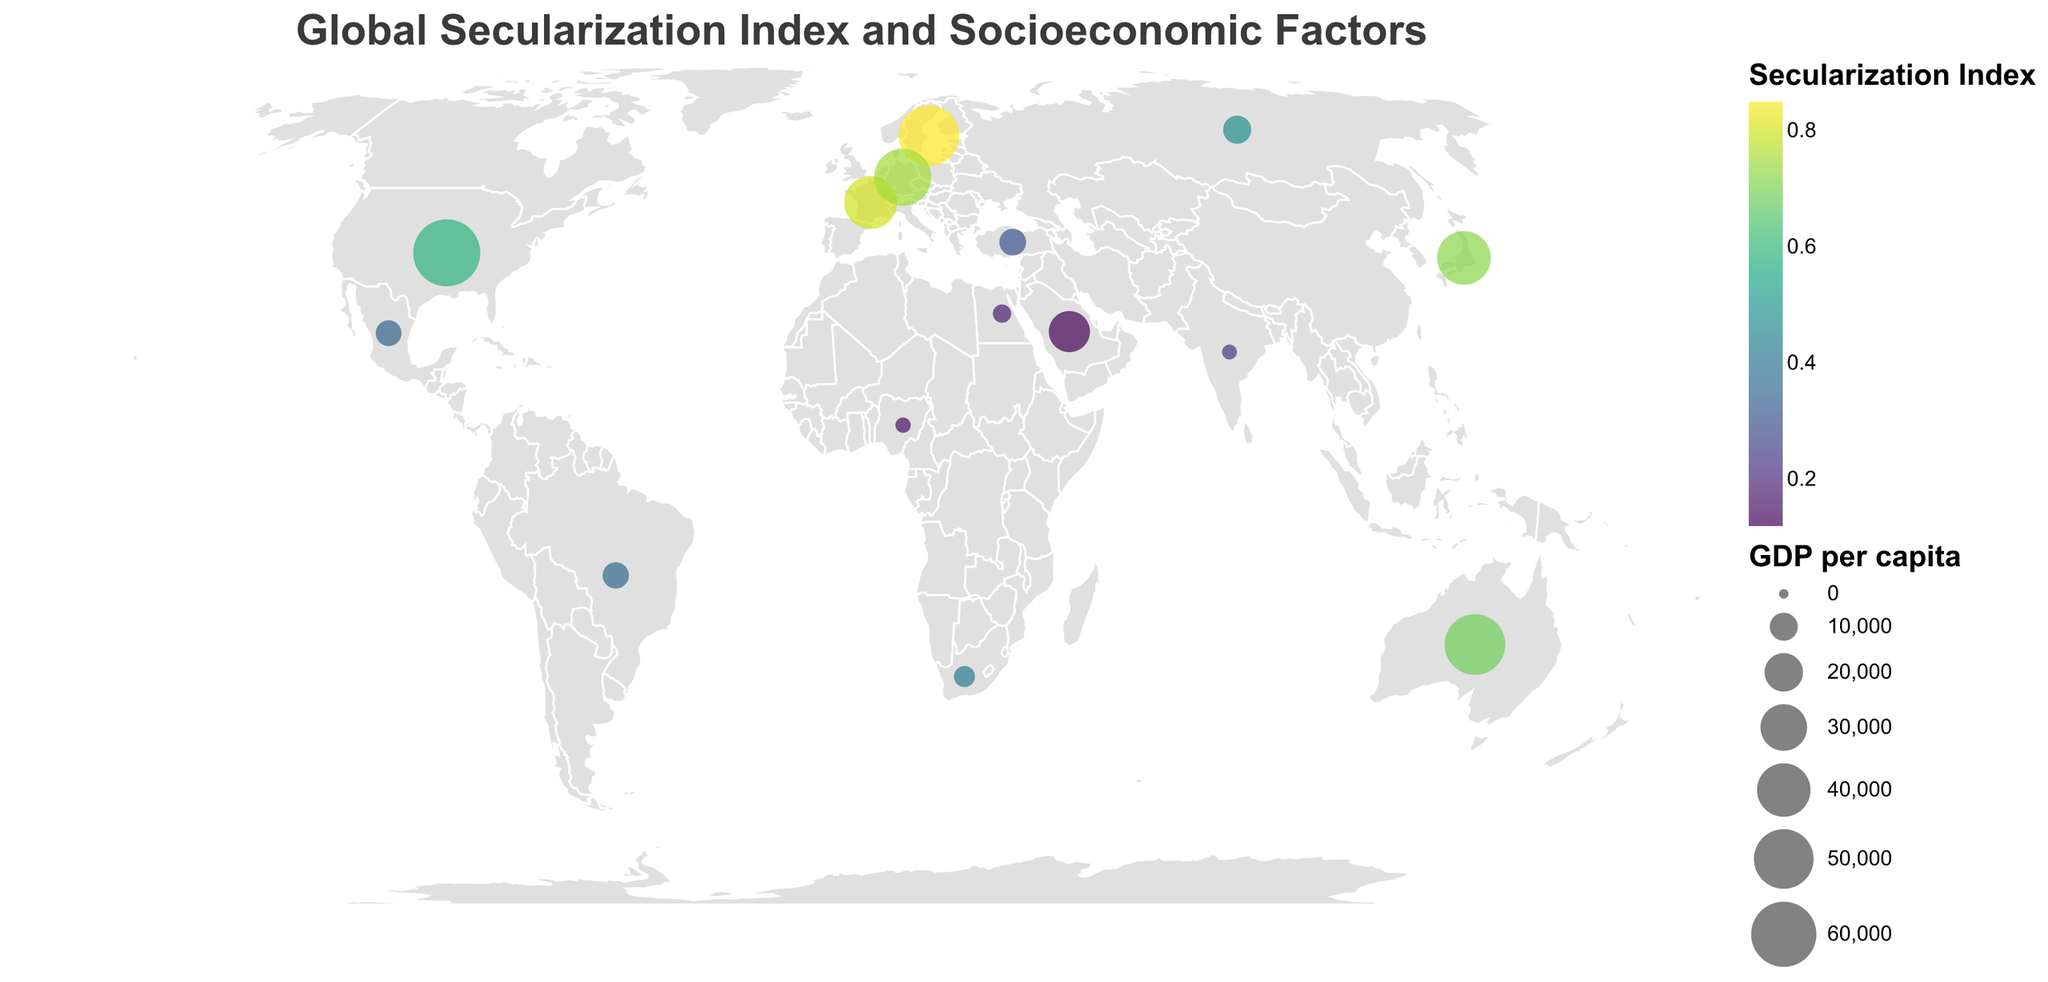What is the title of the figure? The title is prominently displayed at the top of the figure in a larger font size. It reads "Global Secularization Index and Socioeconomic Factors."
Answer: Global Secularization Index and Socioeconomic Factors Which country has the highest Secularization Index? By looking at the color coding on the map, the country with the highest Secularization Index will be the one with the deepest color in the range of the viridis color scale.
Answer: Sweden How does the size of the circle represent socioeconomic factors on the map? The size of the circle is proportionate to the GDP per capita. Larger circles indicate higher GDP per capita and smaller circles indicate lower GDP per capita.
Answer: Proportional to GDP per capita Which countries have a Secularization Index above 0.70 and what are their GDP per capita values? We look for the countries marked with deep colors corresponding to Secularization Index values above 0.70. Then, identify their GDP per capita values shown in the legend.
Answer: Sweden (51615), Japan (40247), France (39030), Germany (45724) Is there a visible relationship between the Secularization Index and Education Index? By comparing the color of the circles (which indicates the Secularization Index) and considering the information on Education Index provided, it appears that countries with higher Secularization Index tend to have higher Education Index values.
Answer: Positive correlation Which countries have both a low Secularization Index (below 0.30) and low GDP per capita (below $10,000)? By looking at smaller circles with lighter colors, these countries are identified.
Answer: Saudi Arabia, India, Nigeria, Egypt Between the United States and Germany, which country has a higher Urbanization Rate and how much difference is there? Comparing the two countries' Urbanization Rates, the United States has 82.7% and Germany has 77.5%. Subtracting these gives the difference.
Answer: United States with a difference of 5.2% How does the geographic location help interpret the Secularization Index in different countries? Understanding the latitude and longitude coordinates helps to locate these countries on the map. Certain regions like Western Europe and parts of East Asia exhibit higher Secularization Indexes, indicating possible regional trends.
Answer: Regional trends observed in Western Europe and East Asia Which country has both a high Urbanization Rate (above 80%) and a low Secularization Index (below 0.20)? By looking for countries with large circles (high Urbanization Rate) that have light colors (low Secularization Index), the specific country can be identified.
Answer: Saudi Arabia 